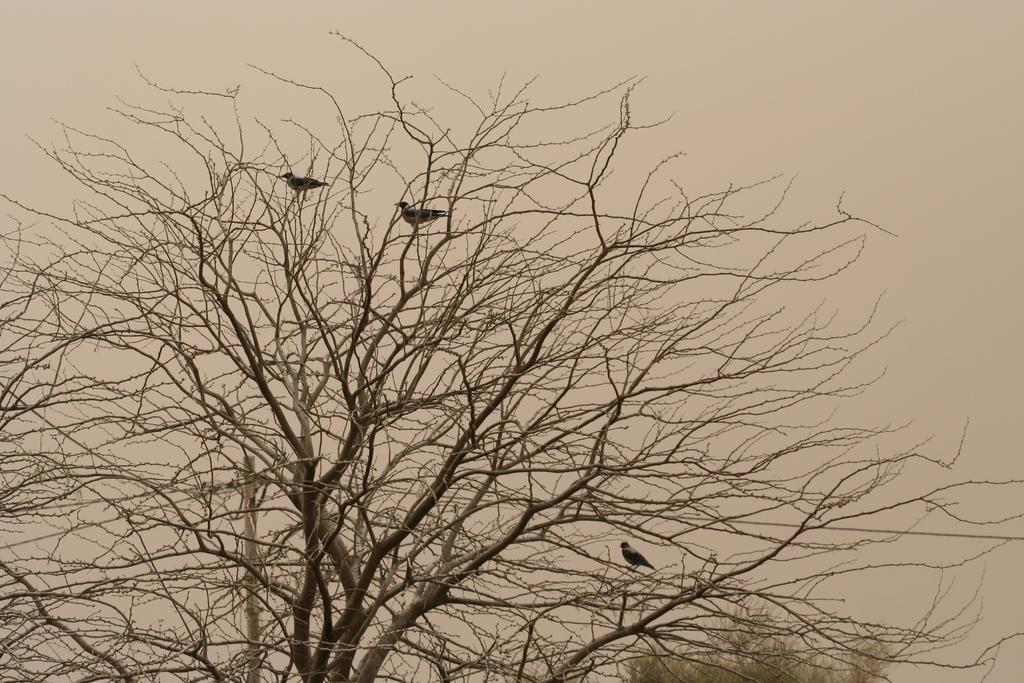How would you summarize this image in a sentence or two? In the foreground of this image, there are three birds on a tree where there are no leaves. In the background, there is a pole, a tree and the sky. 